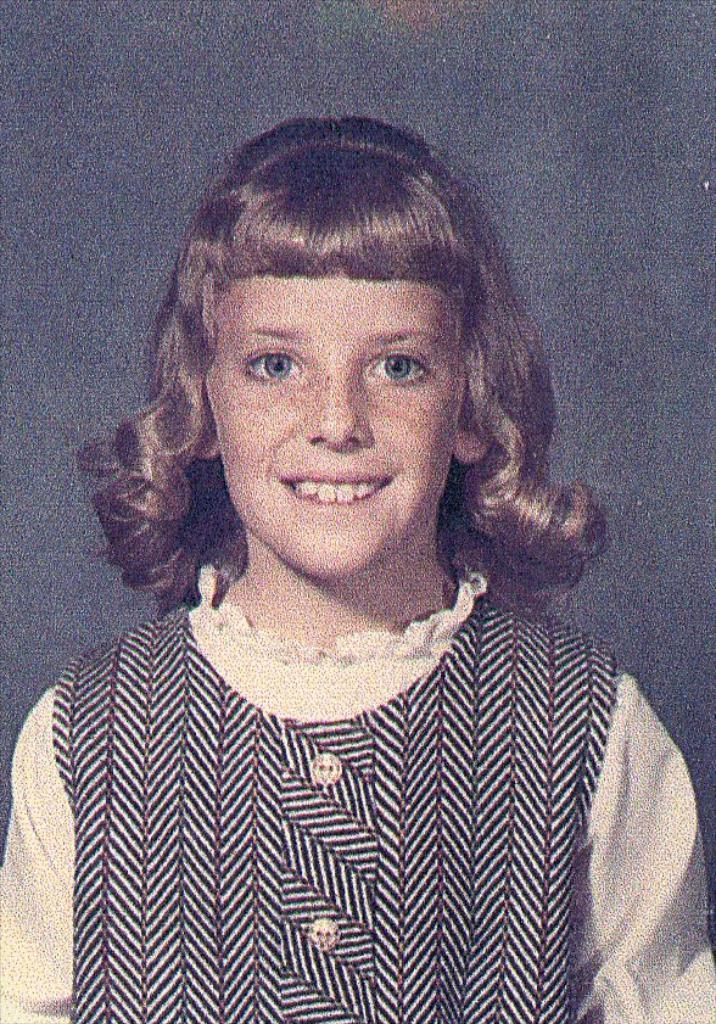What is the main subject of the image? There is a picture of a girl in the image. How is the girl depicted in the image? The girl is smiling. What type of bell can be heard ringing in the image? There is no bell present in the image, and therefore no sound can be heard. What punishment is the girl receiving in the image? The girl is smiling, which suggests she is not receiving any punishment in the image. 